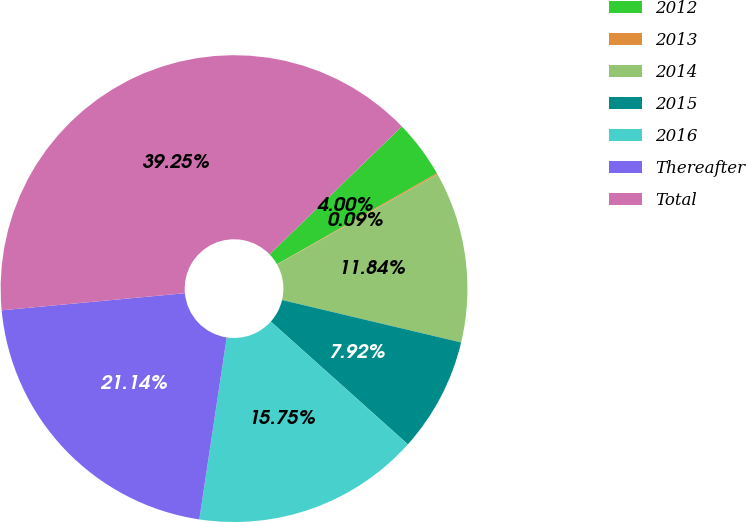Convert chart to OTSL. <chart><loc_0><loc_0><loc_500><loc_500><pie_chart><fcel>2012<fcel>2013<fcel>2014<fcel>2015<fcel>2016<fcel>Thereafter<fcel>Total<nl><fcel>4.0%<fcel>0.09%<fcel>11.84%<fcel>7.92%<fcel>15.75%<fcel>21.14%<fcel>39.25%<nl></chart> 